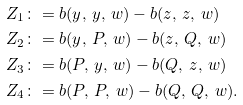Convert formula to latex. <formula><loc_0><loc_0><loc_500><loc_500>Z _ { 1 } & \colon = b ( y , \, y , \, w ) - b ( z , \, z , \, w ) \\ Z _ { 2 } & \colon = b ( y , \, P , \, w ) - b ( z , \, Q , \, w ) \\ Z _ { 3 } & \colon = b ( P , \, y , \, w ) - b ( Q , \, z , \, w ) \\ Z _ { 4 } & \colon = b ( P , \, P , \, w ) - b ( Q , \, Q , \, w ) .</formula> 